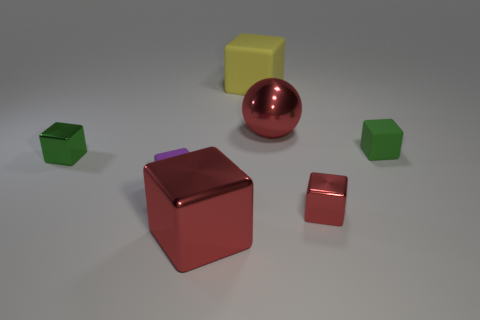Subtract all yellow rubber cubes. How many cubes are left? 5 Add 3 purple objects. How many objects exist? 10 Subtract all balls. How many objects are left? 6 Subtract all cyan cylinders. How many red blocks are left? 2 Subtract all purple cubes. How many cubes are left? 5 Subtract all gray spheres. Subtract all blue cubes. How many spheres are left? 1 Subtract all red shiny spheres. Subtract all blocks. How many objects are left? 0 Add 2 small purple blocks. How many small purple blocks are left? 3 Add 2 green rubber things. How many green rubber things exist? 3 Subtract 0 blue cubes. How many objects are left? 7 